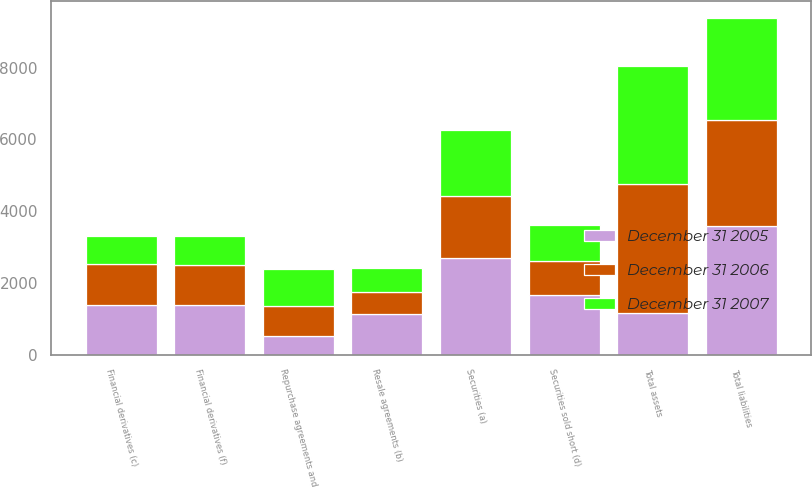Convert chart to OTSL. <chart><loc_0><loc_0><loc_500><loc_500><stacked_bar_chart><ecel><fcel>Securities (a)<fcel>Resale agreements (b)<fcel>Financial derivatives (c)<fcel>Total assets<fcel>Securities sold short (d)<fcel>Repurchase agreements and<fcel>Financial derivatives (f)<fcel>Total liabilities<nl><fcel>December 31 2005<fcel>2708<fcel>1133<fcel>1378<fcel>1148<fcel>1657<fcel>520<fcel>1384<fcel>3600<nl><fcel>December 31 2006<fcel>1712<fcel>623<fcel>1148<fcel>3611<fcel>965<fcel>833<fcel>1103<fcel>2932<nl><fcel>December 31 2007<fcel>1850<fcel>663<fcel>772<fcel>3285<fcel>993<fcel>1044<fcel>825<fcel>2862<nl></chart> 